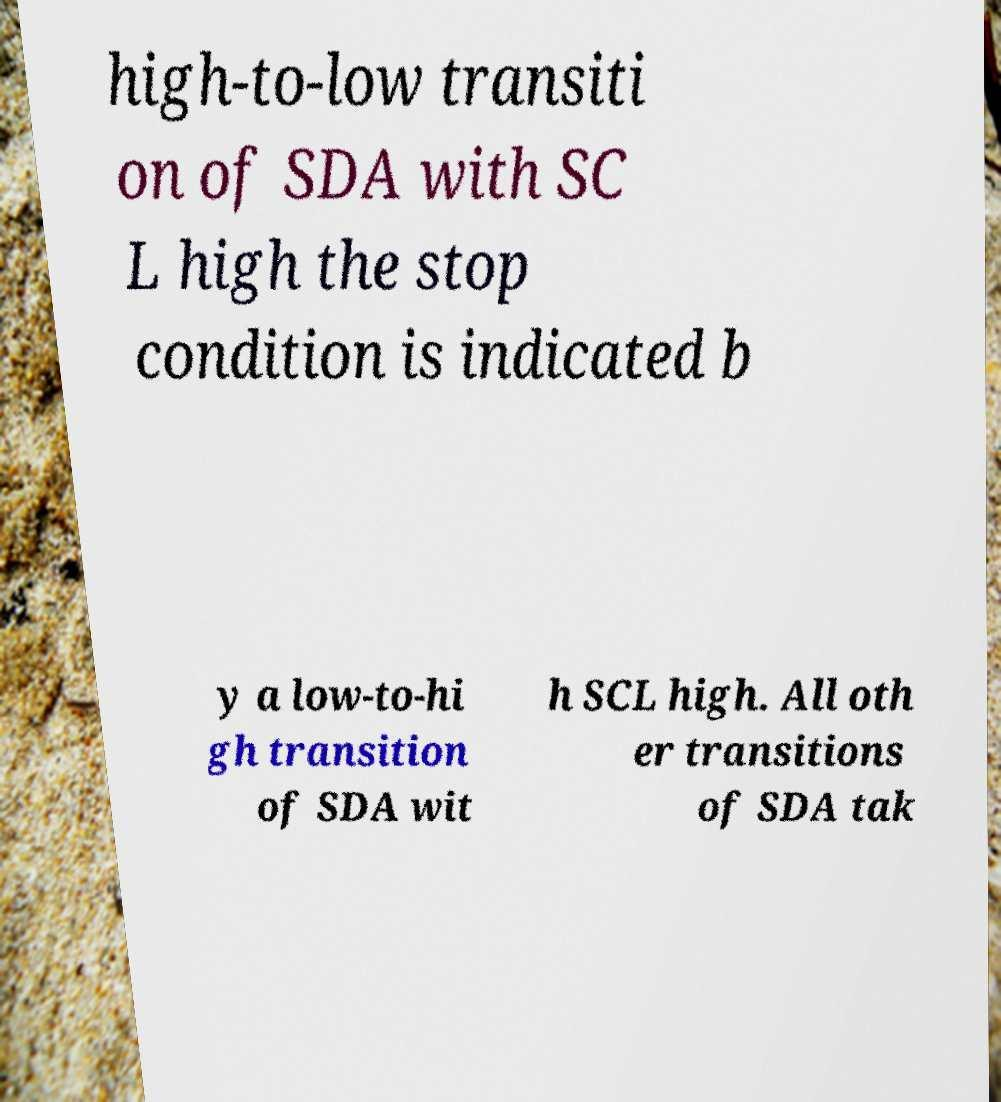Could you extract and type out the text from this image? high-to-low transiti on of SDA with SC L high the stop condition is indicated b y a low-to-hi gh transition of SDA wit h SCL high. All oth er transitions of SDA tak 